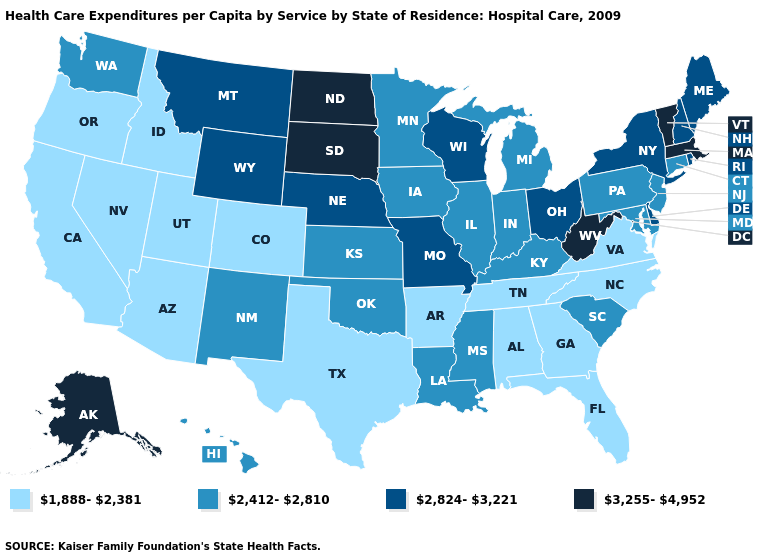What is the value of Florida?
Short answer required. 1,888-2,381. What is the value of Kansas?
Write a very short answer. 2,412-2,810. Does Washington have the same value as Oregon?
Give a very brief answer. No. Does Louisiana have the lowest value in the USA?
Write a very short answer. No. Name the states that have a value in the range 3,255-4,952?
Give a very brief answer. Alaska, Massachusetts, North Dakota, South Dakota, Vermont, West Virginia. What is the highest value in the MidWest ?
Be succinct. 3,255-4,952. What is the value of Arkansas?
Keep it brief. 1,888-2,381. Name the states that have a value in the range 1,888-2,381?
Keep it brief. Alabama, Arizona, Arkansas, California, Colorado, Florida, Georgia, Idaho, Nevada, North Carolina, Oregon, Tennessee, Texas, Utah, Virginia. What is the value of Wisconsin?
Write a very short answer. 2,824-3,221. What is the value of Kentucky?
Short answer required. 2,412-2,810. What is the value of Illinois?
Write a very short answer. 2,412-2,810. Name the states that have a value in the range 2,824-3,221?
Give a very brief answer. Delaware, Maine, Missouri, Montana, Nebraska, New Hampshire, New York, Ohio, Rhode Island, Wisconsin, Wyoming. How many symbols are there in the legend?
Be succinct. 4. Does the map have missing data?
Give a very brief answer. No. What is the lowest value in the West?
Concise answer only. 1,888-2,381. 